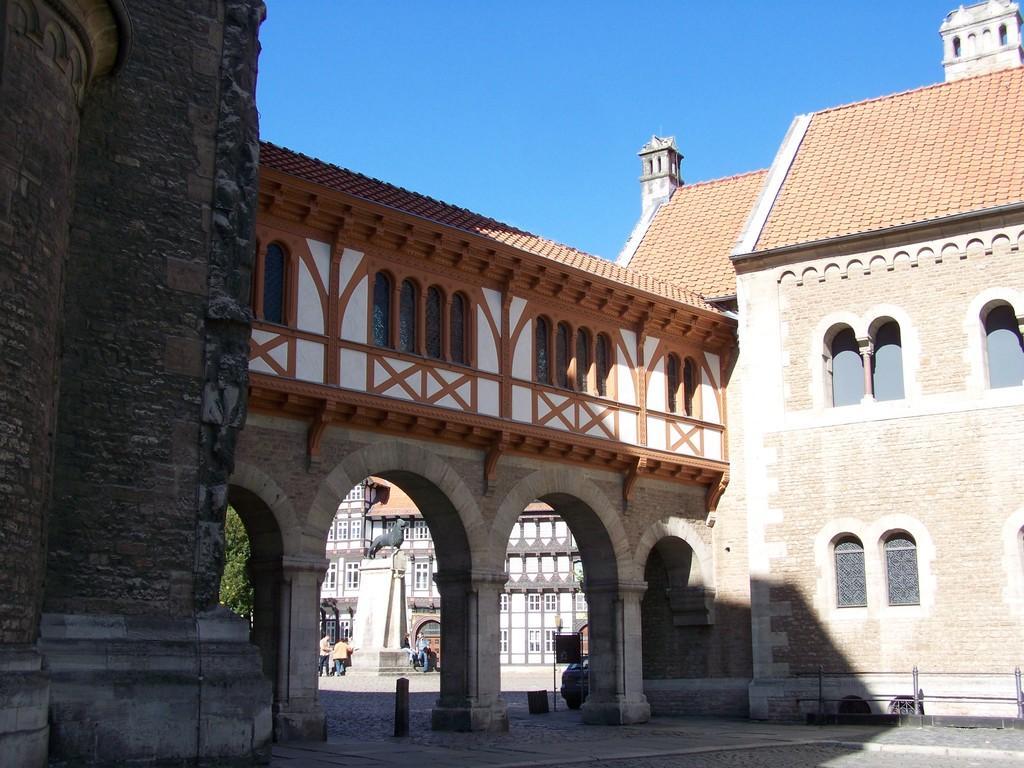Describe this image in one or two sentences. This image is taken outdoors. At the top of the image there is the sky. At the bottom of the image there is a floor. On the left side of the image there is an architecture with walls and carvings. In the background there is a building and a few people are standing on the road. There is a tree and there is a sculpture. On the right side of the image there is a building with walls, windows and a roof. In the middle of the image there are three pillars and there are a few windows. 